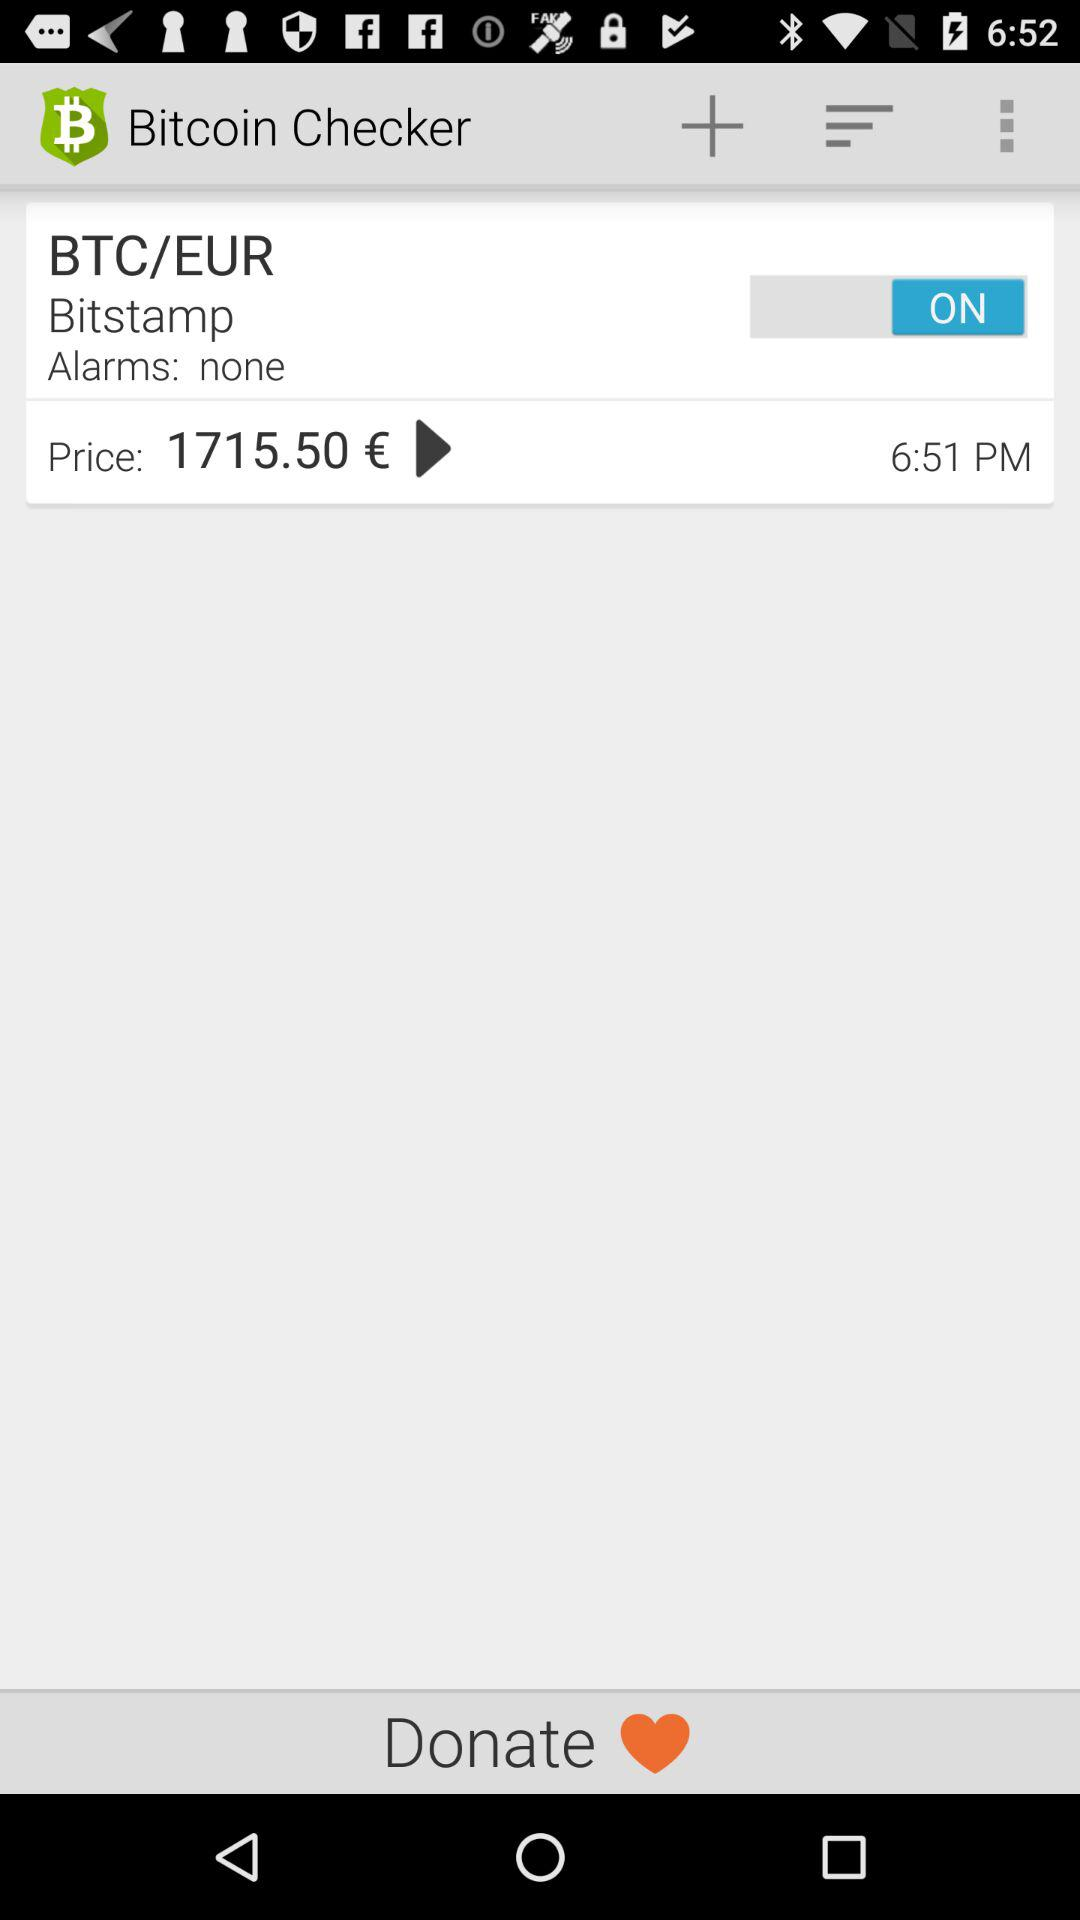Are there any alarms? There is no alarm. 